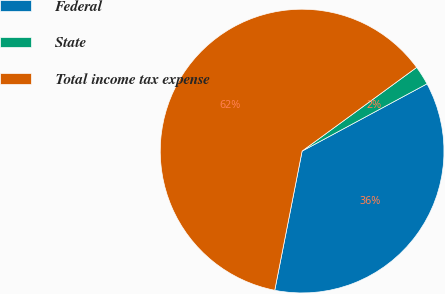<chart> <loc_0><loc_0><loc_500><loc_500><pie_chart><fcel>Federal<fcel>State<fcel>Total income tax expense<nl><fcel>35.95%<fcel>2.18%<fcel>61.87%<nl></chart> 